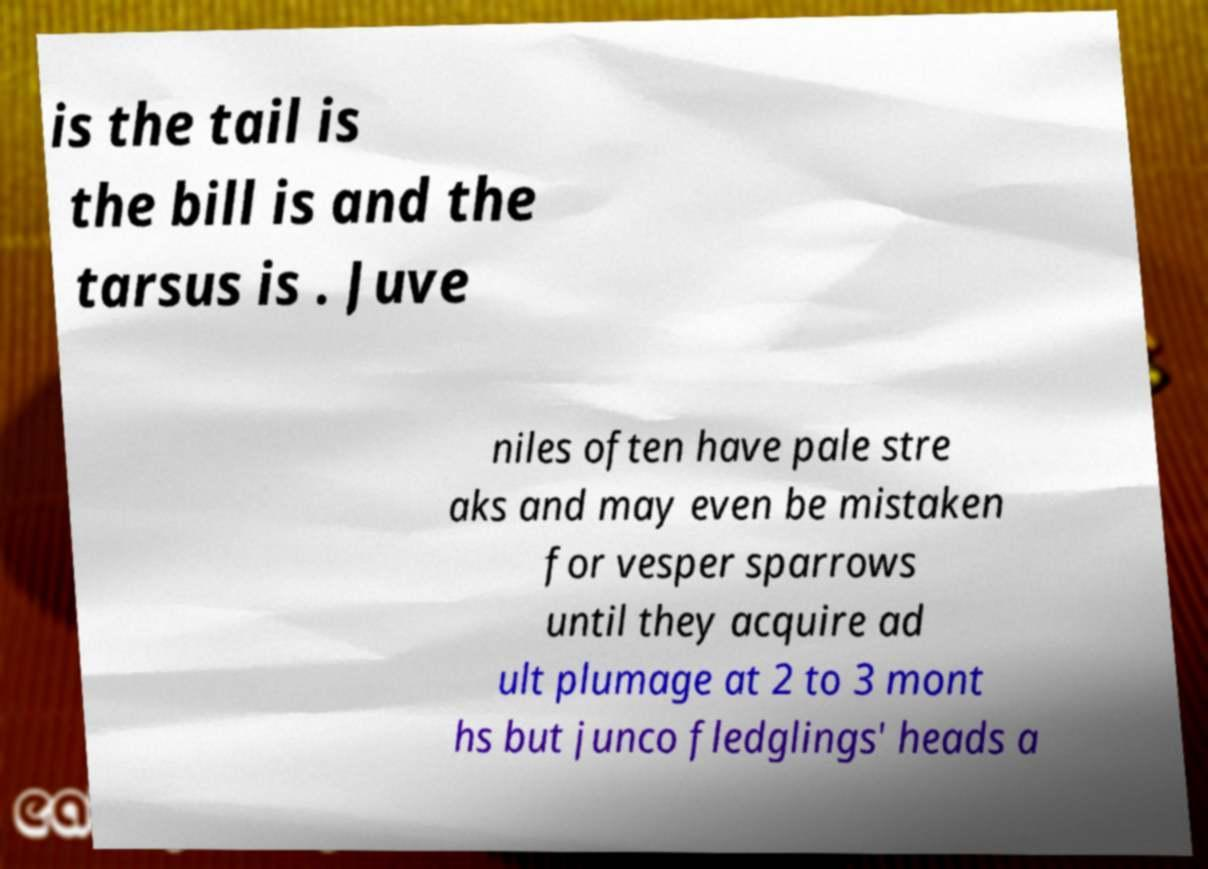Could you extract and type out the text from this image? is the tail is the bill is and the tarsus is . Juve niles often have pale stre aks and may even be mistaken for vesper sparrows until they acquire ad ult plumage at 2 to 3 mont hs but junco fledglings' heads a 